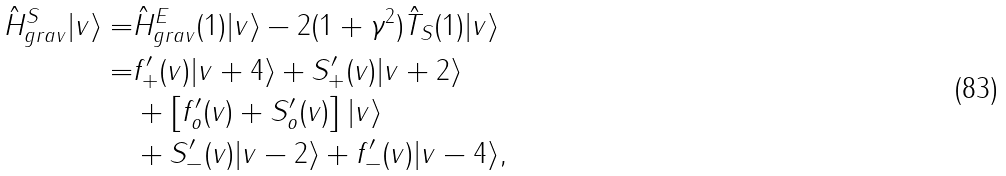<formula> <loc_0><loc_0><loc_500><loc_500>\hat { H } ^ { S } _ { g r a v } | v \rangle = & \hat { H } ^ { E } _ { g r a v } ( 1 ) | v \rangle - 2 ( 1 + \gamma ^ { 2 } ) \hat { T } _ { S } ( 1 ) | v \rangle \\ = & f ^ { \prime } _ { + } ( v ) | v + 4 \rangle + S ^ { \prime } _ { + } ( v ) | v + 2 \rangle \\ & + \left [ f ^ { \prime } _ { o } ( v ) + S ^ { \prime } _ { o } ( v ) \right ] | v \rangle \\ & + S ^ { \prime } _ { - } ( v ) | v - 2 \rangle + f ^ { \prime } _ { - } ( v ) | v - 4 \rangle ,</formula> 